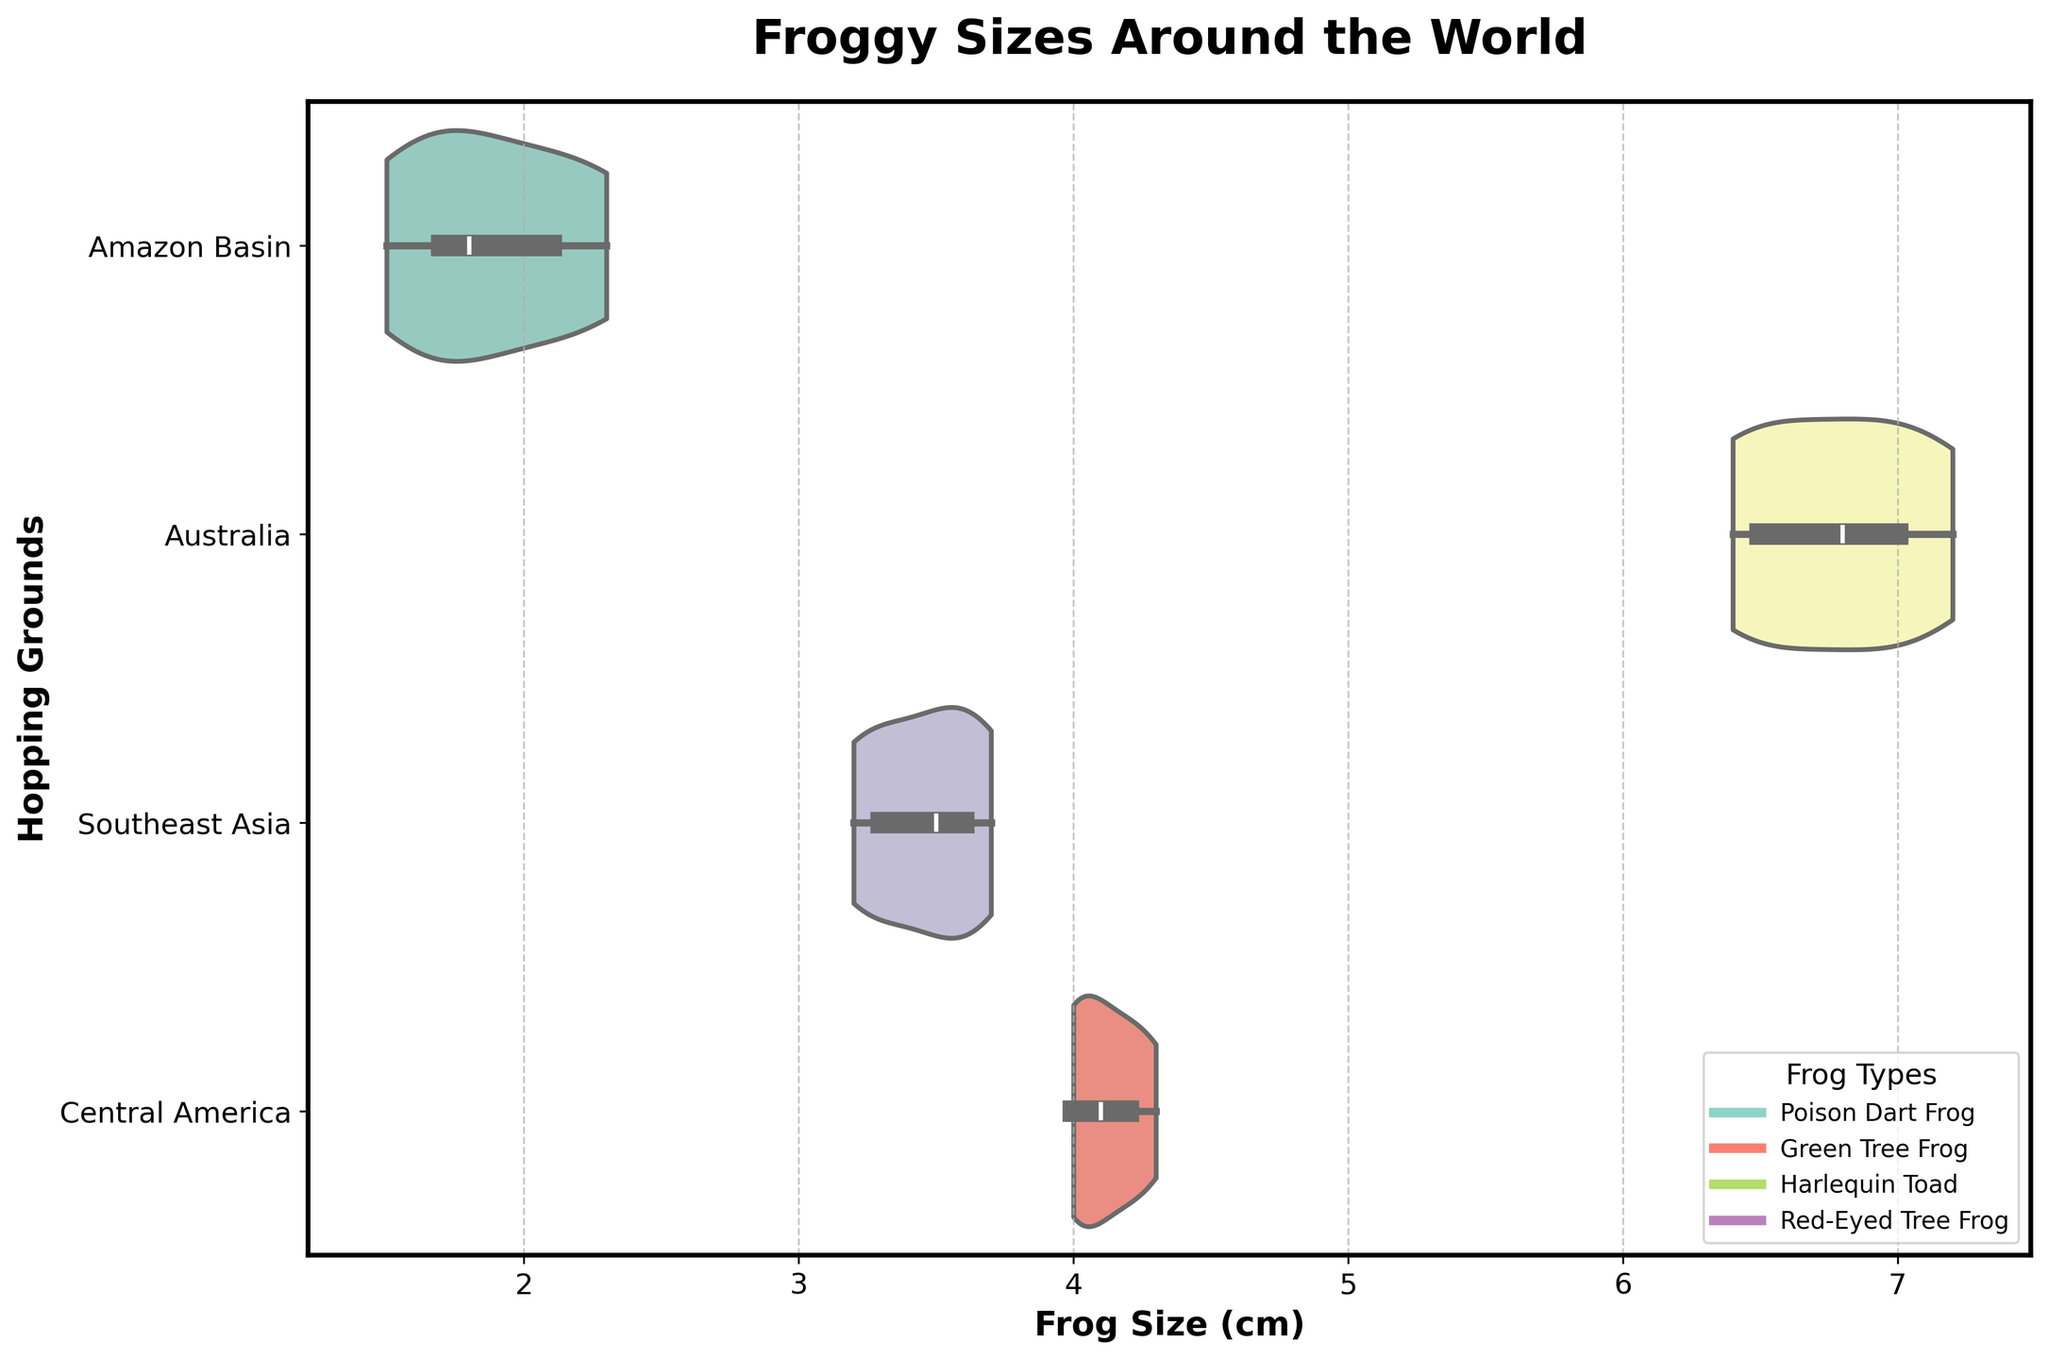What is the title of the chart? The title is located at the top of the chart. It is styled in a bold, larger font to stand out from other text attributes.
Answer: Froggy Sizes Around the World Which region shows the smallest frog sizes? Based on the horizontal spread of the violin plots along the x-axis, the region with the smallest frog sizes appears the leftmost.
Answer: Amazon Basin What is the range of frog sizes in the Australia region? Look at the span of the Australia violin plot along the x-axis to observe the minimum and maximum values.
Answer: 6.4 cm to 7.2 cm In which region do frogs have the greatest variation in size? Observe the width of the violin plots. The region with the widest plot indicates the greatest spread of frog sizes.
Answer: Amazon Basin Which two regions have frog sizes that overlap significantly? Compare the violin plots, focusing on where their ranges on the x-axis intersect.
Answer: Central America and Southeast Asia What is the median frog size in the Southeast Asia region? The median frog size can typically be identified by the thickest part of the violin plot. Alternatively, look for any inner box plot elements indicating the median.
Answer: About 3.5 cm How do the sizes of frogs in the Central America region compare to those in the Southeast Asia region? Compare the horizontal spread of the Central America and Southeast Asia violin plots for any visual overlap or distinct differences.
Answer: Central America frogs are slightly larger Which frog species is found in Central America, and how does its size compare to the species found in the Amazon Basin? The legend indicates the frog species in each region. Compare the spread of the two regions' violin plots along the x-axis for size differences.
Answer: Red-Eyed Tree Frog, larger than Poison Dart Frog Which region’s frogs are mostly medium-sized based on the chart? Determine this by analyzing which region’s violin plot has the most data centrally clustered without extreme high or low sizes.
Answer: Southeast Asia 